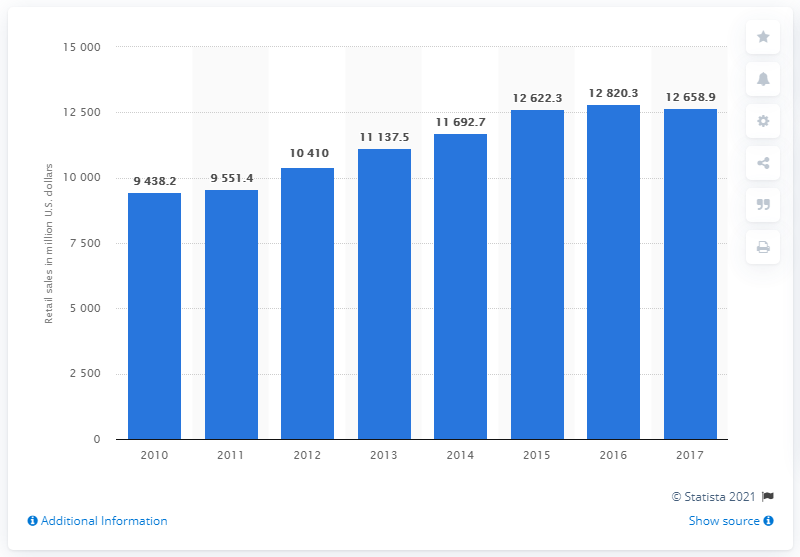Mention a couple of crucial points in this snapshot. In 2017, the retail sales of lenses for eyewear in the United States generated a total of $126,589.9 million. 